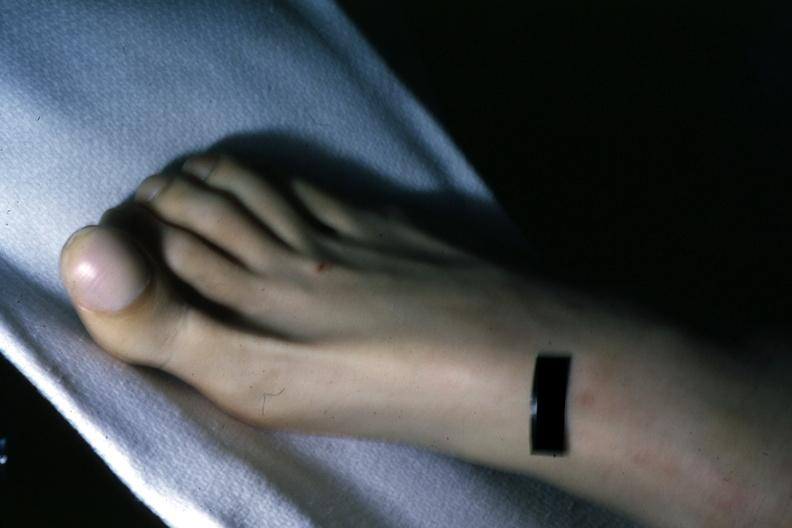does feet show clubbing?
Answer the question using a single word or phrase. No 